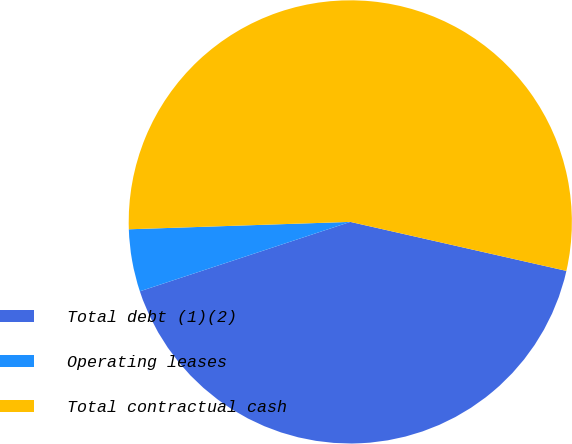Convert chart. <chart><loc_0><loc_0><loc_500><loc_500><pie_chart><fcel>Total debt (1)(2)<fcel>Operating leases<fcel>Total contractual cash<nl><fcel>41.38%<fcel>4.54%<fcel>54.08%<nl></chart> 